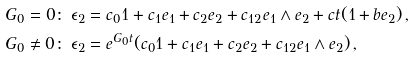<formula> <loc_0><loc_0><loc_500><loc_500>& G _ { 0 } = 0 \colon \, \epsilon _ { 2 } = c _ { 0 } 1 + c _ { 1 } e _ { 1 } + c _ { 2 } e _ { 2 } + c _ { 1 2 } e _ { 1 } \wedge e _ { 2 } + c t ( 1 + b e _ { 2 } ) \, , \\ & G _ { 0 } \neq 0 \colon \, \epsilon _ { 2 } = e ^ { G _ { 0 } t } ( c _ { 0 } 1 + c _ { 1 } e _ { 1 } + c _ { 2 } e _ { 2 } + c _ { 1 2 } e _ { 1 } \wedge e _ { 2 } ) \, ,</formula> 